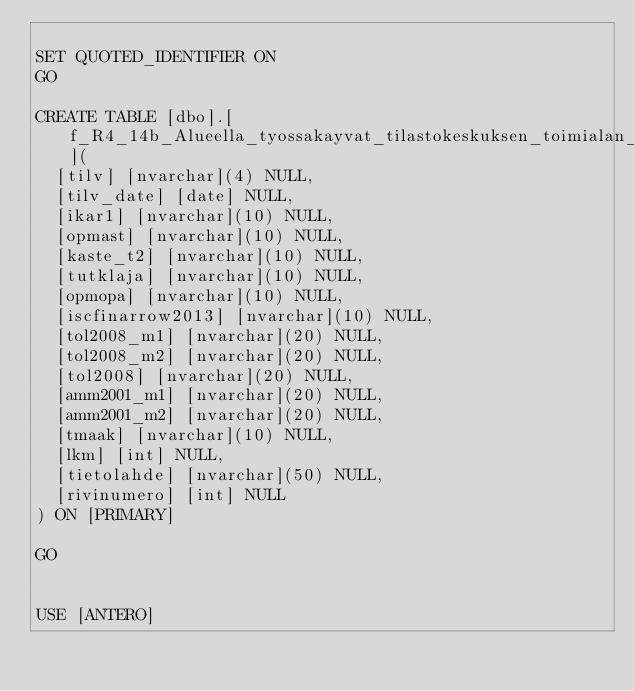<code> <loc_0><loc_0><loc_500><loc_500><_SQL_>
SET QUOTED_IDENTIFIER ON
GO

CREATE TABLE [dbo].[f_R4_14b_Alueella_tyossakayvat_tilastokeskuksen_toimialan_mukaan](
	[tilv] [nvarchar](4) NULL,
	[tilv_date] [date] NULL,
	[ikar1] [nvarchar](10) NULL,
	[opmast] [nvarchar](10) NULL,
	[kaste_t2] [nvarchar](10) NULL,
	[tutklaja] [nvarchar](10) NULL,
	[opmopa] [nvarchar](10) NULL,
	[iscfinarrow2013] [nvarchar](10) NULL,
	[tol2008_m1] [nvarchar](20) NULL,
	[tol2008_m2] [nvarchar](20) NULL,
	[tol2008] [nvarchar](20) NULL,
	[amm2001_m1] [nvarchar](20) NULL,
	[amm2001_m2] [nvarchar](20) NULL,
	[tmaak] [nvarchar](10) NULL,
	[lkm] [int] NULL,
	[tietolahde] [nvarchar](50) NULL,
	[rivinumero] [int] NULL
) ON [PRIMARY]

GO


USE [ANTERO]</code> 